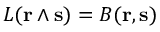<formula> <loc_0><loc_0><loc_500><loc_500>L ( r \wedge s ) = B ( r , s )</formula> 